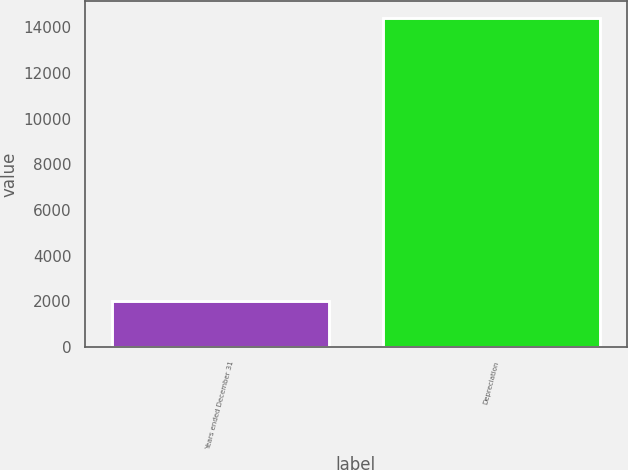<chart> <loc_0><loc_0><loc_500><loc_500><bar_chart><fcel>Years ended December 31<fcel>Depreciation<nl><fcel>2013<fcel>14415<nl></chart> 